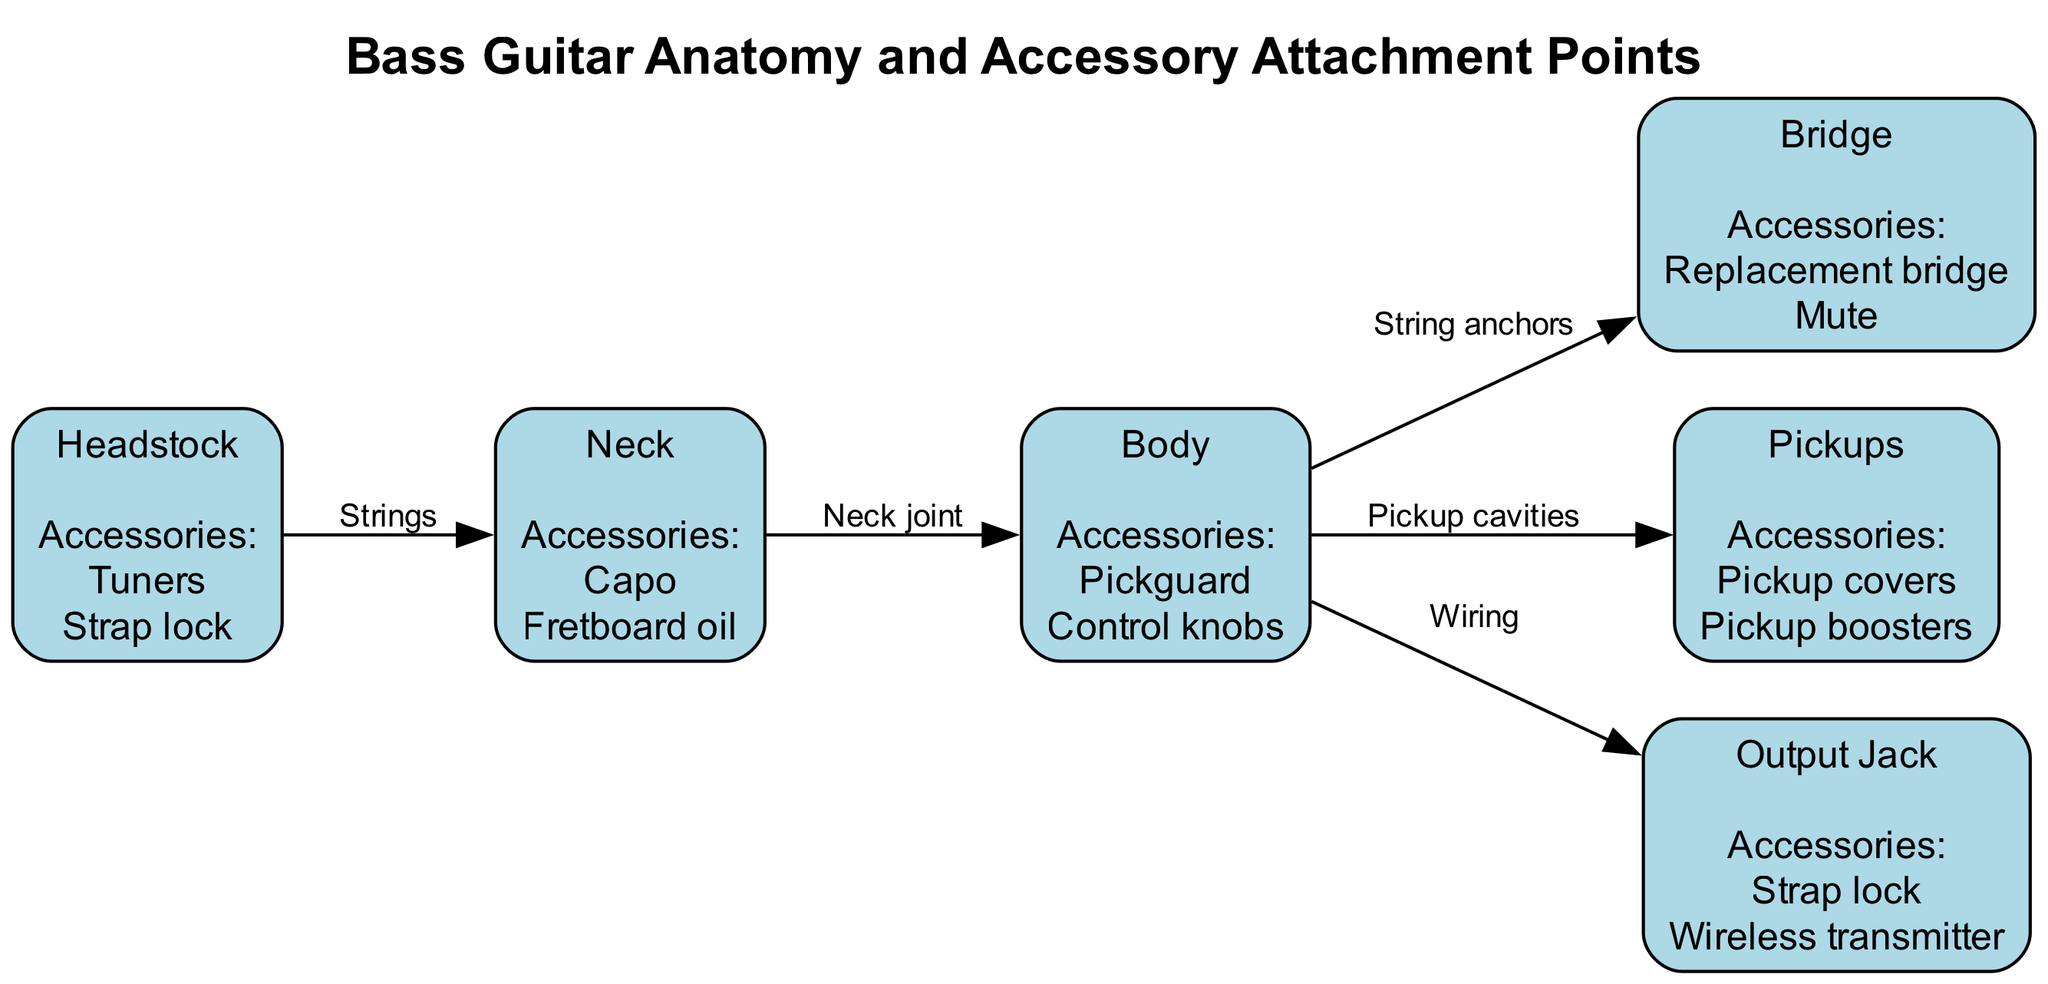What accessories can be attached to the Headstock? The diagram lists the accessories for each node. For the Headstock node, the accessories specified are "Tuners" and "Strap lock".
Answer: Tuners, Strap lock How many nodes are present in the diagram? To find the number of nodes, we can simply count them from the diagram's nodes list, which has six nodes: Headstock, Neck, Bridge, Pickups, Body, and Output Jack.
Answer: 6 What accessories are commonly used with the Bridge? By examining the accessories linked to the Bridge node in the diagram, we find that the accessories are "Replacement bridge" and "Mute".
Answer: Replacement bridge, Mute Which two nodes are directly connected by the edge labeled "Neck joint"? The diagram shows connections between nodes. The edge labeled "Neck joint" connects the Neck node to the Body node directly.
Answer: Neck, Body What is the relationship between the Body and the Output Jack? The diagram illustrates that the Body node is connected to the Output Jack node through an edge labeled "Wiring", indicating a direct relationship where wiring connects these two components.
Answer: Wiring What accessories could be added to Pickups? By looking at the accessories associated with the Pickups node in the diagram, we see that "Pickup covers" and "Pickup boosters" can be attached.
Answer: Pickup covers, Pickup boosters How many total accessories are indicated for the Neck, and what are they? The Neck node shows that a total of two accessories can be attached: "Capo" and "Fretboard oil". This can be deduced by counting the accessories listed for that node.
Answer: 2, Capo, Fretboard oil What is the edge connecting the Body to the Bridge labeled as? The diagram specifies that the edge connecting the Body node to the Bridge node is labeled "String anchors", which denotes the function or purpose of this connection.
Answer: String anchors Which accessory is unique to the Output Jack compared to the other components? The Output Jack node has "Wireless transmitter" as one of its accessories. This accessory is not mentioned for any other node, making it unique within this diagram's accessory listings.
Answer: Wireless transmitter 